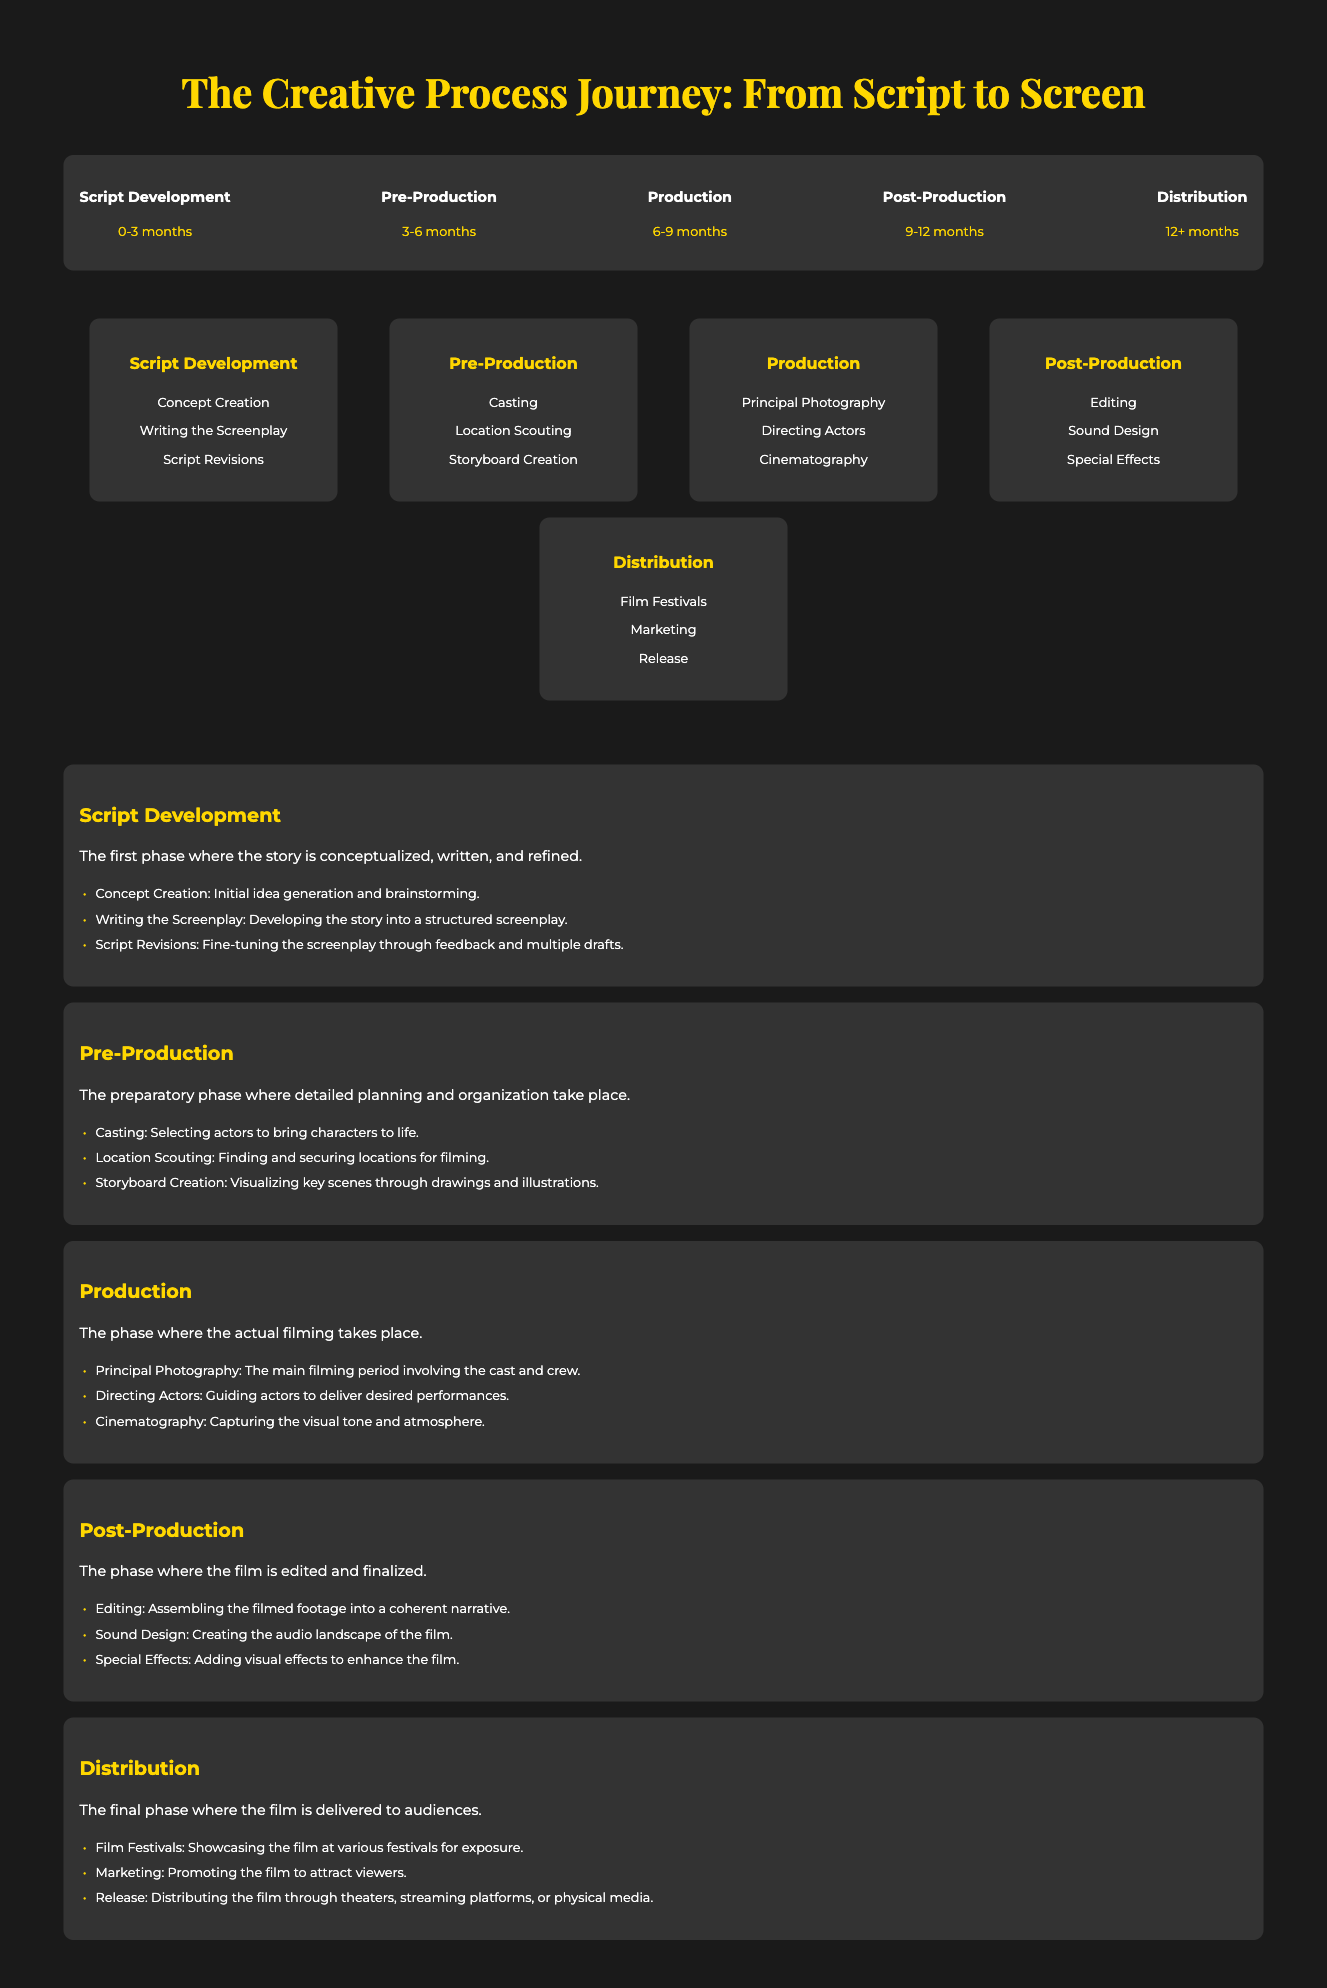What is the first phase of the creative process? The infographic lists "Script Development" as the first phase in the timeline.
Answer: Script Development How long does the Pre-Production phase last? According to the timeline, the duration of the Pre-Production phase is specified as 3-6 months.
Answer: 3-6 months What are the three key activities in the Production phase? The document outlines three main activities: "Principal Photography", "Directing Actors", and "Cinematography".
Answer: Principal Photography, Directing Actors, Cinematography What is involved in the Post-Production phase? The flowchart section on Post-Production highlights "Editing", "Sound Design", and "Special Effects" as key components.
Answer: Editing, Sound Design, Special Effects In which phase is "Casting" performed? "Casting" is identified as an activity under the Pre-Production phase in the flowchart.
Answer: Pre-Production What is the final phase before the film reaches audiences? The infographic describes "Distribution" as the final phase in the creative process journey.
Answer: Distribution How many milestones are described in the document? The document outlines five distinct phases or milestones in the creative process journey.
Answer: Five What is the primary focus of the Script Development phase? The description for this phase emphasizes the conceptualization and refinement of the story.
Answer: Conceptualization and refinement Which milestone includes "Film Festivals" as an activity? The "Distribution" phase includes "Film Festivals" as part of its activities for audience reach.
Answer: Distribution 